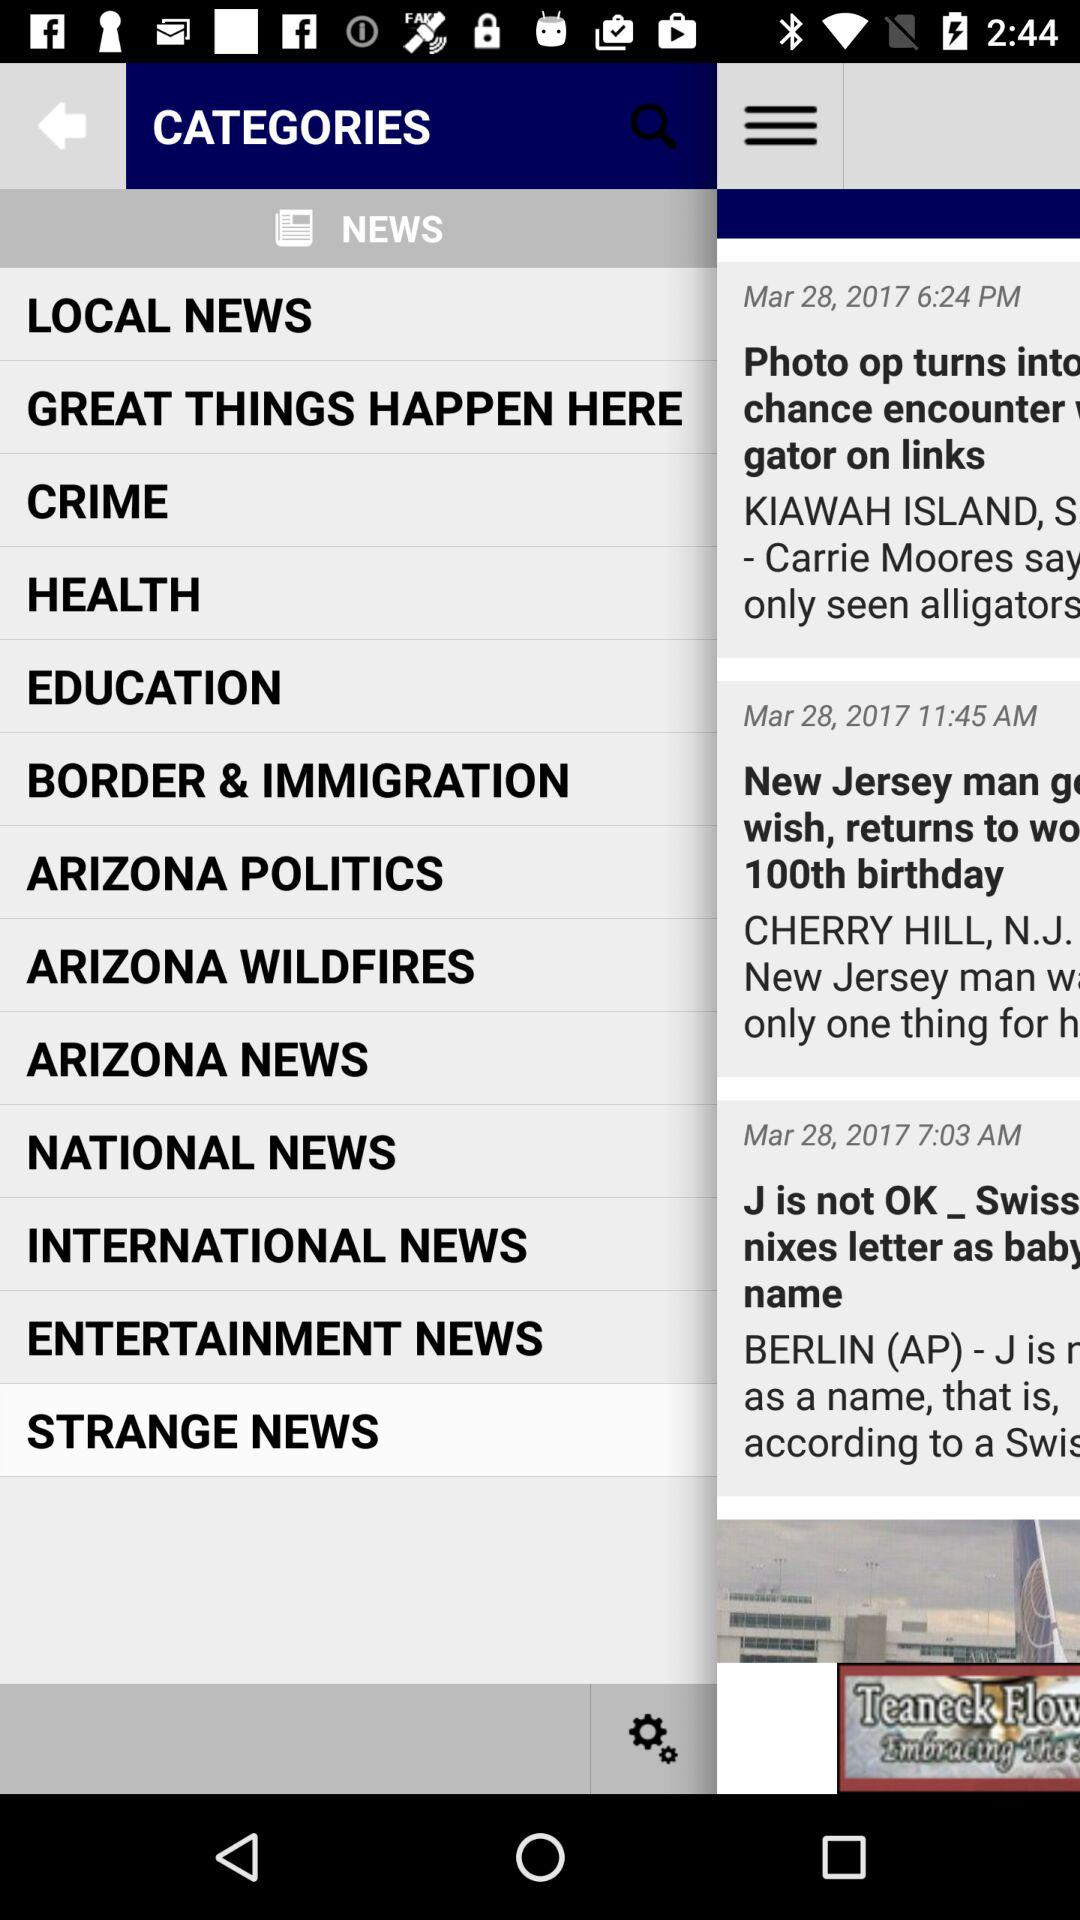Which categories of news are selected? The selected category is "Strange News". 